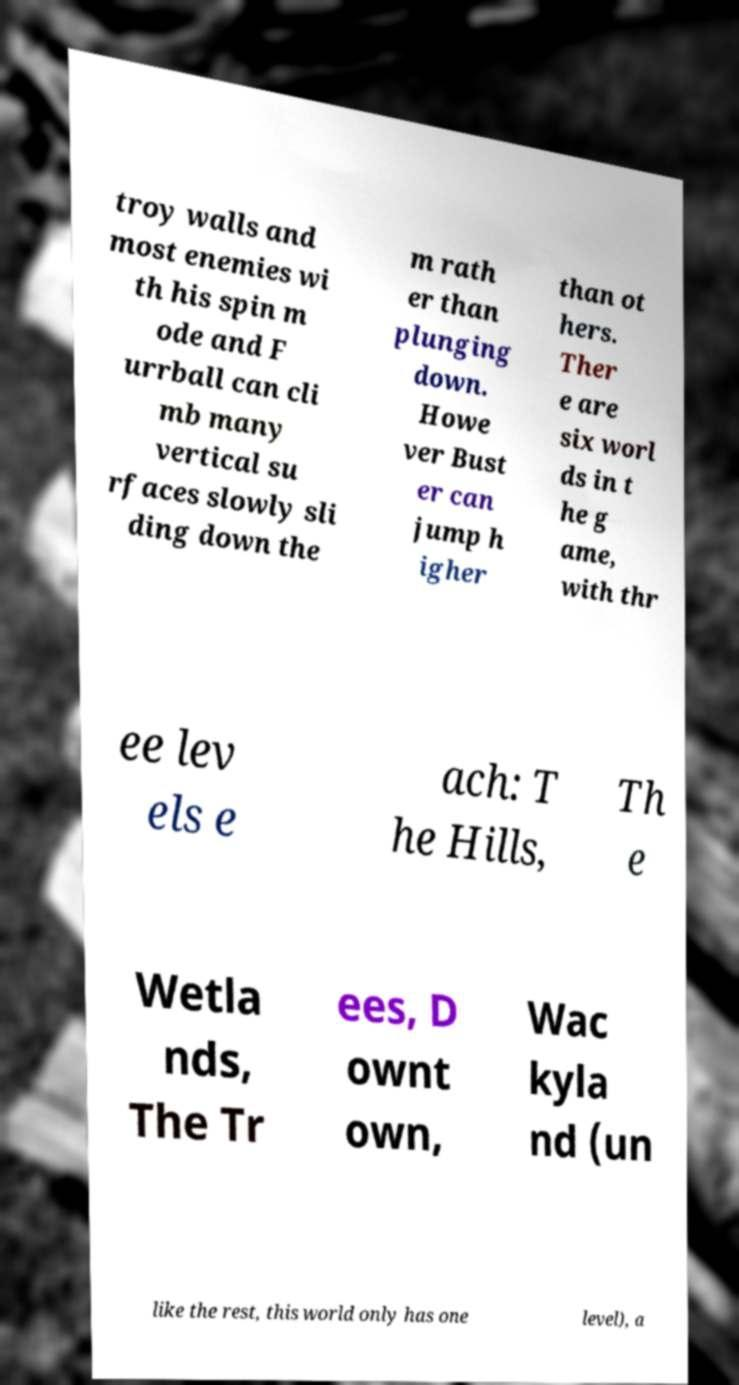For documentation purposes, I need the text within this image transcribed. Could you provide that? troy walls and most enemies wi th his spin m ode and F urrball can cli mb many vertical su rfaces slowly sli ding down the m rath er than plunging down. Howe ver Bust er can jump h igher than ot hers. Ther e are six worl ds in t he g ame, with thr ee lev els e ach: T he Hills, Th e Wetla nds, The Tr ees, D ownt own, Wac kyla nd (un like the rest, this world only has one level), a 